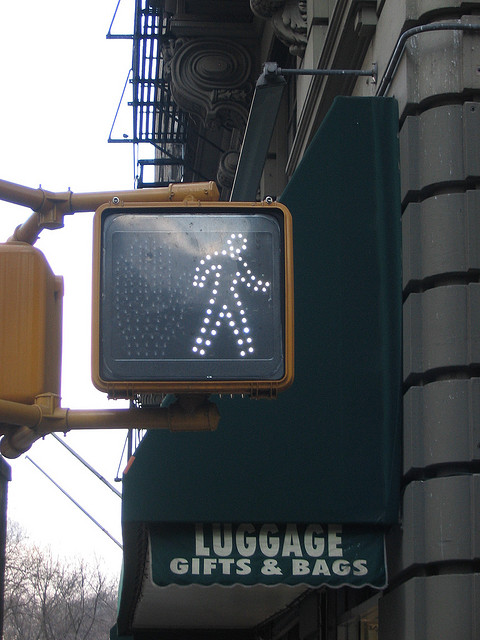Identify and read out the text in this image. LUGGAGE GIFTS BAGS 